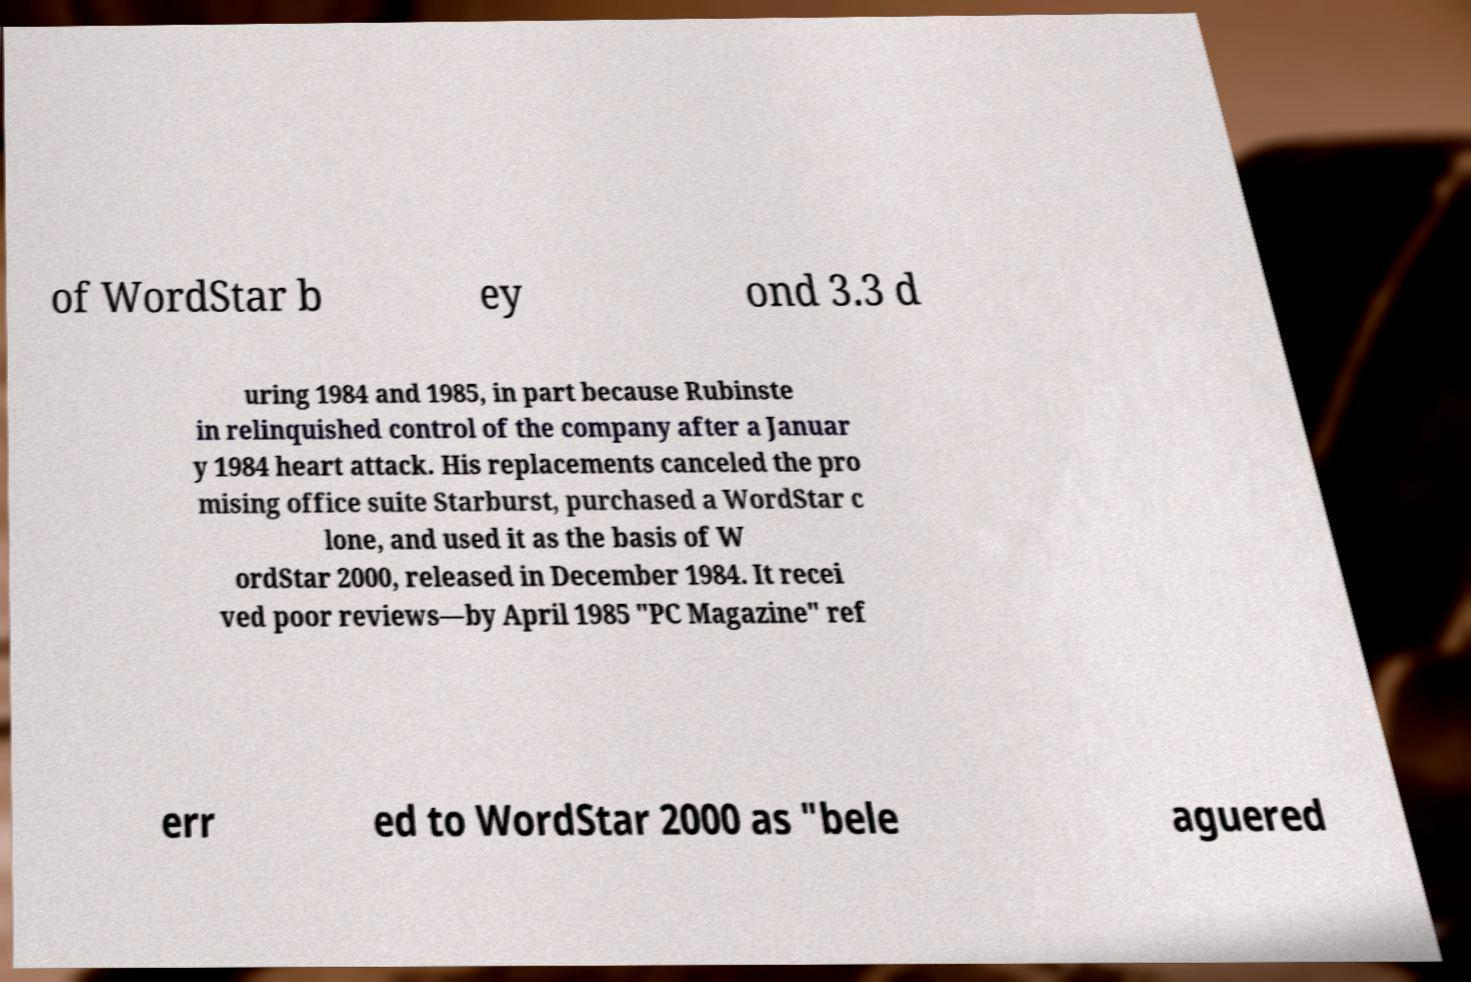There's text embedded in this image that I need extracted. Can you transcribe it verbatim? of WordStar b ey ond 3.3 d uring 1984 and 1985, in part because Rubinste in relinquished control of the company after a Januar y 1984 heart attack. His replacements canceled the pro mising office suite Starburst, purchased a WordStar c lone, and used it as the basis of W ordStar 2000, released in December 1984. It recei ved poor reviews—by April 1985 "PC Magazine" ref err ed to WordStar 2000 as "bele aguered 